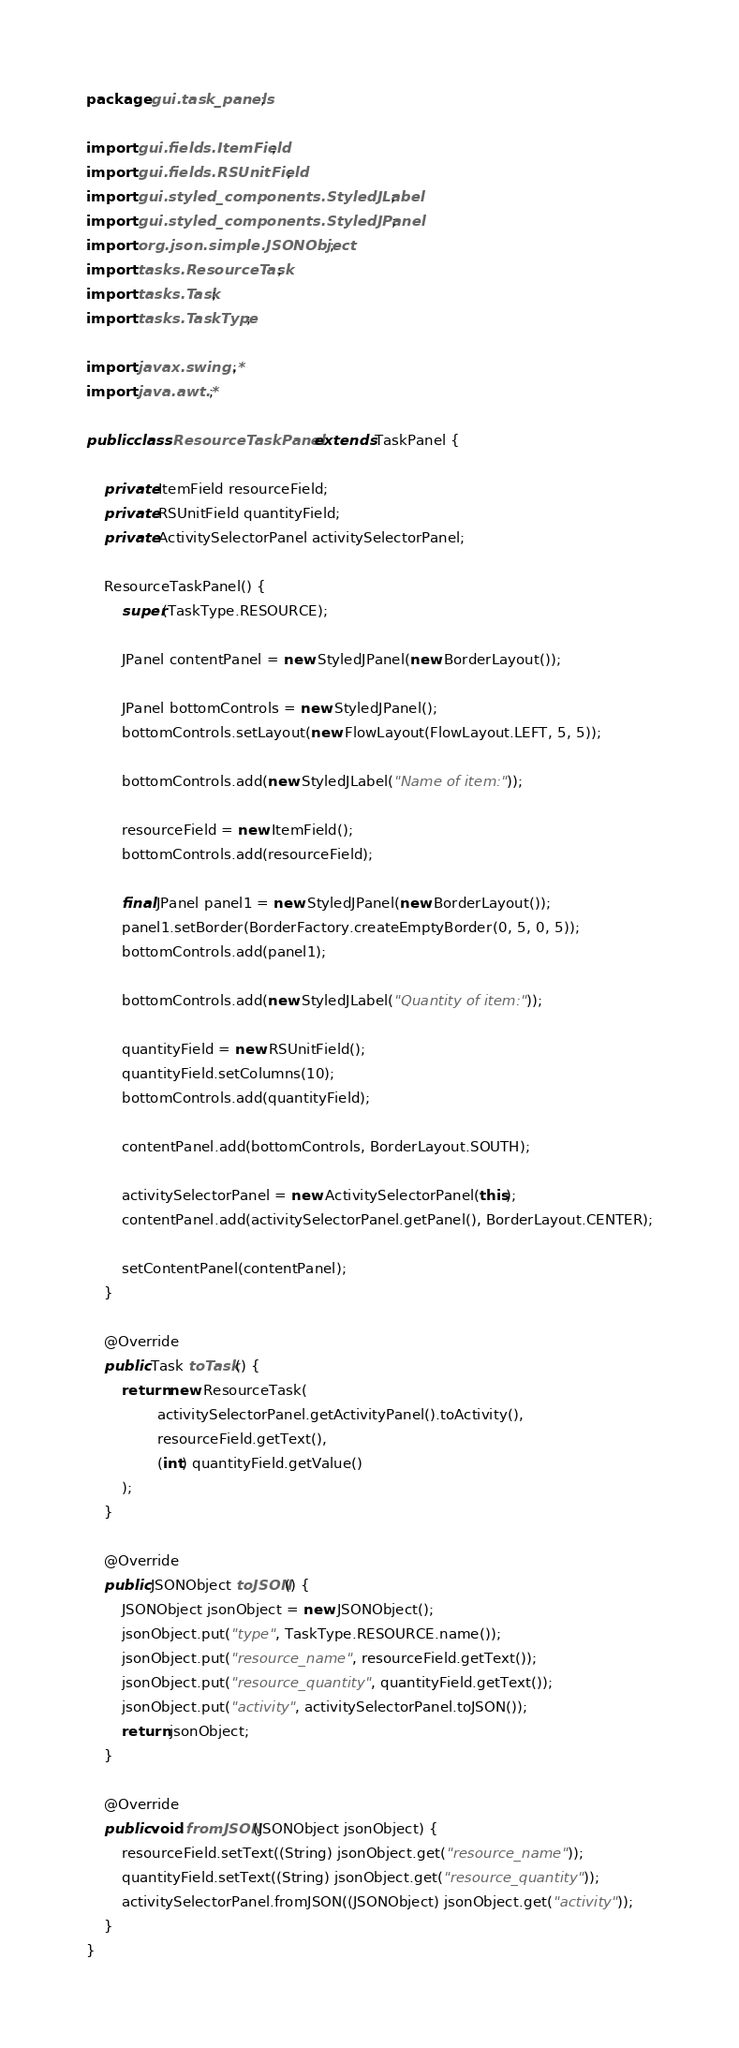<code> <loc_0><loc_0><loc_500><loc_500><_Java_>package gui.task_panels;

import gui.fields.ItemField;
import gui.fields.RSUnitField;
import gui.styled_components.StyledJLabel;
import gui.styled_components.StyledJPanel;
import org.json.simple.JSONObject;
import tasks.ResourceTask;
import tasks.Task;
import tasks.TaskType;

import javax.swing.*;
import java.awt.*;

public class ResourceTaskPanel extends TaskPanel {

    private ItemField resourceField;
    private RSUnitField quantityField;
    private ActivitySelectorPanel activitySelectorPanel;

    ResourceTaskPanel() {
        super(TaskType.RESOURCE);

        JPanel contentPanel = new StyledJPanel(new BorderLayout());

        JPanel bottomControls = new StyledJPanel();
        bottomControls.setLayout(new FlowLayout(FlowLayout.LEFT, 5, 5));

        bottomControls.add(new StyledJLabel("Name of item:"));

        resourceField = new ItemField();
        bottomControls.add(resourceField);

        final JPanel panel1 = new StyledJPanel(new BorderLayout());
        panel1.setBorder(BorderFactory.createEmptyBorder(0, 5, 0, 5));
        bottomControls.add(panel1);

        bottomControls.add(new StyledJLabel("Quantity of item:"));

        quantityField = new RSUnitField();
        quantityField.setColumns(10);
        bottomControls.add(quantityField);

        contentPanel.add(bottomControls, BorderLayout.SOUTH);

        activitySelectorPanel = new ActivitySelectorPanel(this);
        contentPanel.add(activitySelectorPanel.getPanel(), BorderLayout.CENTER);

        setContentPanel(contentPanel);
    }

    @Override
    public Task toTask() {
        return new ResourceTask(
                activitySelectorPanel.getActivityPanel().toActivity(),
                resourceField.getText(),
                (int) quantityField.getValue()
        );
    }

    @Override
    public JSONObject toJSON() {
        JSONObject jsonObject = new JSONObject();
        jsonObject.put("type", TaskType.RESOURCE.name());
        jsonObject.put("resource_name", resourceField.getText());
        jsonObject.put("resource_quantity", quantityField.getText());
        jsonObject.put("activity", activitySelectorPanel.toJSON());
        return jsonObject;
    }

    @Override
    public void fromJSON(JSONObject jsonObject) {
        resourceField.setText((String) jsonObject.get("resource_name"));
        quantityField.setText((String) jsonObject.get("resource_quantity"));
        activitySelectorPanel.fromJSON((JSONObject) jsonObject.get("activity"));
    }
}
</code> 